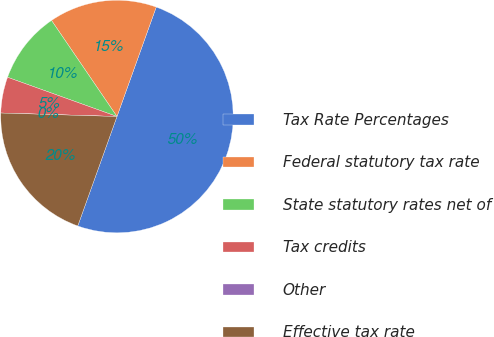Convert chart to OTSL. <chart><loc_0><loc_0><loc_500><loc_500><pie_chart><fcel>Tax Rate Percentages<fcel>Federal statutory tax rate<fcel>State statutory rates net of<fcel>Tax credits<fcel>Other<fcel>Effective tax rate<nl><fcel>49.99%<fcel>15.0%<fcel>10.0%<fcel>5.0%<fcel>0.0%<fcel>20.0%<nl></chart> 